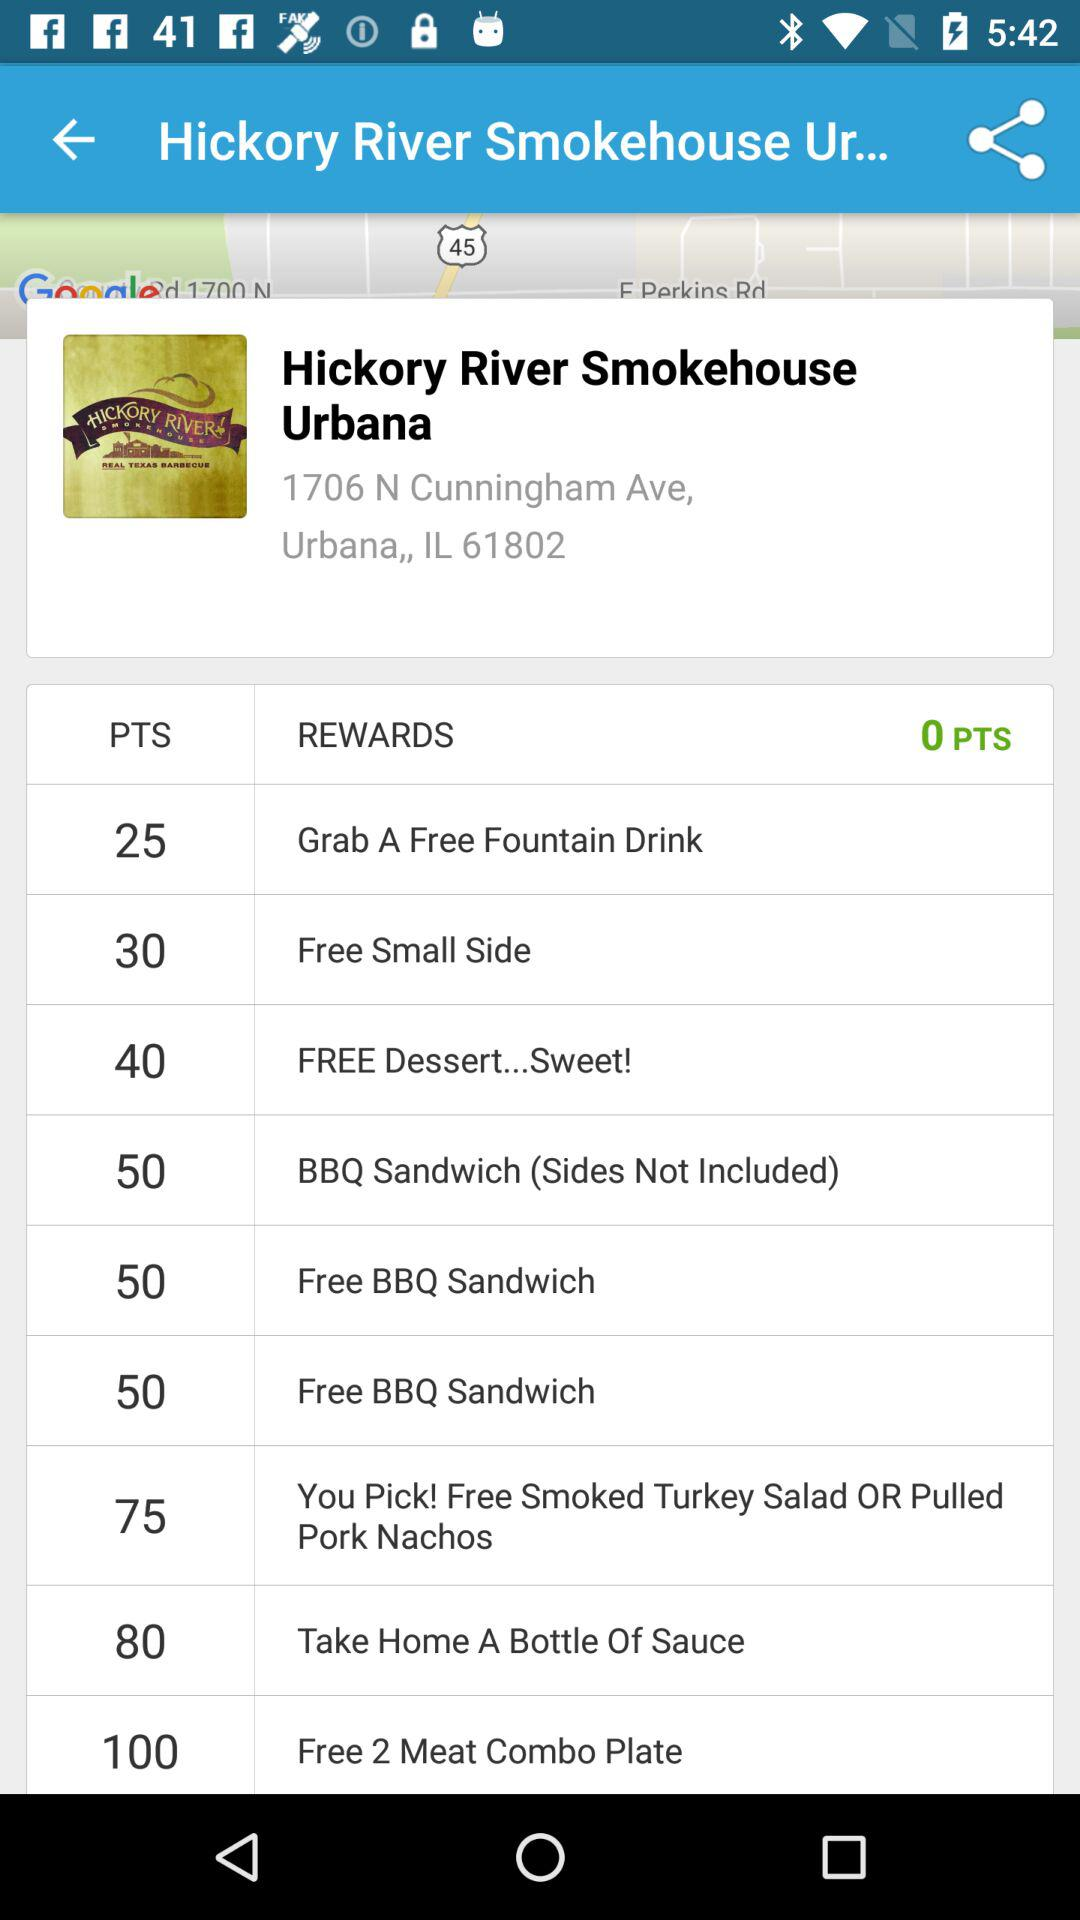What is the address of "Hickory River Smokehouse Urbana"? The address is 1706 N. Cunningham Ave., Urbana, IL 61802. 